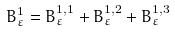Convert formula to latex. <formula><loc_0><loc_0><loc_500><loc_500>B _ { \varepsilon } ^ { 1 } = B _ { \varepsilon } ^ { 1 , 1 } + B _ { \varepsilon } ^ { 1 , 2 } + B _ { \varepsilon } ^ { 1 , 3 }</formula> 